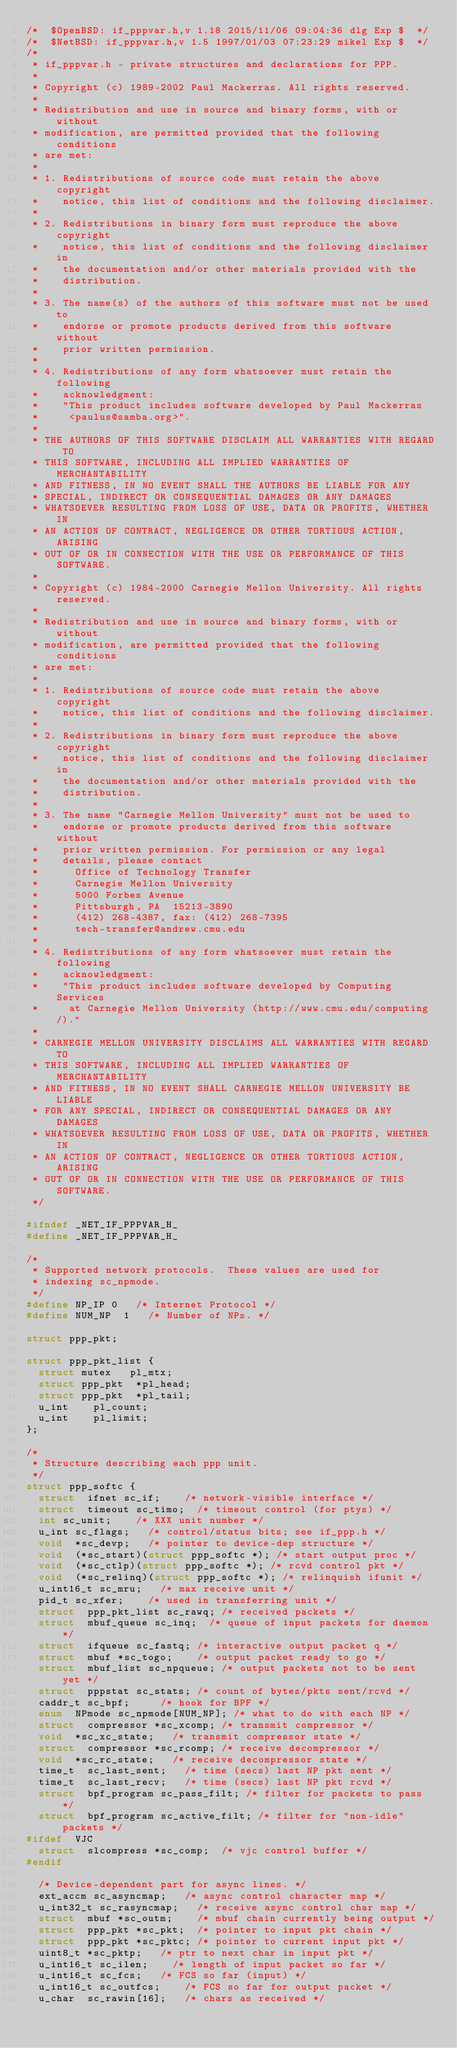Convert code to text. <code><loc_0><loc_0><loc_500><loc_500><_C_>/*	$OpenBSD: if_pppvar.h,v 1.18 2015/11/06 09:04:36 dlg Exp $	*/
/*	$NetBSD: if_pppvar.h,v 1.5 1997/01/03 07:23:29 mikel Exp $	*/
/*
 * if_pppvar.h - private structures and declarations for PPP.
 *
 * Copyright (c) 1989-2002 Paul Mackerras. All rights reserved.
 *
 * Redistribution and use in source and binary forms, with or without
 * modification, are permitted provided that the following conditions
 * are met:
 *
 * 1. Redistributions of source code must retain the above copyright
 *    notice, this list of conditions and the following disclaimer.
 *
 * 2. Redistributions in binary form must reproduce the above copyright
 *    notice, this list of conditions and the following disclaimer in
 *    the documentation and/or other materials provided with the
 *    distribution.
 *
 * 3. The name(s) of the authors of this software must not be used to
 *    endorse or promote products derived from this software without
 *    prior written permission.
 *
 * 4. Redistributions of any form whatsoever must retain the following
 *    acknowledgment:
 *    "This product includes software developed by Paul Mackerras
 *     <paulus@samba.org>".
 *
 * THE AUTHORS OF THIS SOFTWARE DISCLAIM ALL WARRANTIES WITH REGARD TO
 * THIS SOFTWARE, INCLUDING ALL IMPLIED WARRANTIES OF MERCHANTABILITY
 * AND FITNESS, IN NO EVENT SHALL THE AUTHORS BE LIABLE FOR ANY
 * SPECIAL, INDIRECT OR CONSEQUENTIAL DAMAGES OR ANY DAMAGES
 * WHATSOEVER RESULTING FROM LOSS OF USE, DATA OR PROFITS, WHETHER IN
 * AN ACTION OF CONTRACT, NEGLIGENCE OR OTHER TORTIOUS ACTION, ARISING
 * OUT OF OR IN CONNECTION WITH THE USE OR PERFORMANCE OF THIS SOFTWARE.
 *
 * Copyright (c) 1984-2000 Carnegie Mellon University. All rights reserved.
 *
 * Redistribution and use in source and binary forms, with or without
 * modification, are permitted provided that the following conditions
 * are met:
 *
 * 1. Redistributions of source code must retain the above copyright
 *    notice, this list of conditions and the following disclaimer.
 *
 * 2. Redistributions in binary form must reproduce the above copyright
 *    notice, this list of conditions and the following disclaimer in
 *    the documentation and/or other materials provided with the
 *    distribution.
 *
 * 3. The name "Carnegie Mellon University" must not be used to
 *    endorse or promote products derived from this software without
 *    prior written permission. For permission or any legal
 *    details, please contact
 *      Office of Technology Transfer
 *      Carnegie Mellon University
 *      5000 Forbes Avenue
 *      Pittsburgh, PA  15213-3890
 *      (412) 268-4387, fax: (412) 268-7395
 *      tech-transfer@andrew.cmu.edu
 *
 * 4. Redistributions of any form whatsoever must retain the following
 *    acknowledgment:
 *    "This product includes software developed by Computing Services
 *     at Carnegie Mellon University (http://www.cmu.edu/computing/)."
 *
 * CARNEGIE MELLON UNIVERSITY DISCLAIMS ALL WARRANTIES WITH REGARD TO
 * THIS SOFTWARE, INCLUDING ALL IMPLIED WARRANTIES OF MERCHANTABILITY
 * AND FITNESS, IN NO EVENT SHALL CARNEGIE MELLON UNIVERSITY BE LIABLE
 * FOR ANY SPECIAL, INDIRECT OR CONSEQUENTIAL DAMAGES OR ANY DAMAGES
 * WHATSOEVER RESULTING FROM LOSS OF USE, DATA OR PROFITS, WHETHER IN
 * AN ACTION OF CONTRACT, NEGLIGENCE OR OTHER TORTIOUS ACTION, ARISING
 * OUT OF OR IN CONNECTION WITH THE USE OR PERFORMANCE OF THIS SOFTWARE.
 */

#ifndef _NET_IF_PPPVAR_H_
#define _NET_IF_PPPVAR_H_

/*
 * Supported network protocols.  These values are used for
 * indexing sc_npmode.
 */
#define NP_IP	0		/* Internet Protocol */
#define NUM_NP	1		/* Number of NPs. */

struct ppp_pkt;

struct ppp_pkt_list {
	struct mutex	 pl_mtx;
	struct ppp_pkt	*pl_head;
	struct ppp_pkt	*pl_tail;
	u_int		 pl_count;
	u_int		 pl_limit;
};

/*
 * Structure describing each ppp unit.
 */
struct ppp_softc {
	struct	ifnet sc_if;		/* network-visible interface */
	struct	timeout sc_timo;	/* timeout control (for ptys) */
	int	sc_unit;		/* XXX unit number */
	u_int	sc_flags;		/* control/status bits; see if_ppp.h */
	void	*sc_devp;		/* pointer to device-dep structure */
	void	(*sc_start)(struct ppp_softc *); /* start output proc */
	void	(*sc_ctlp)(struct ppp_softc *); /* rcvd control pkt */
	void	(*sc_relinq)(struct ppp_softc *); /* relinquish ifunit */
	u_int16_t sc_mru;		/* max receive unit */
	pid_t	sc_xfer;		/* used in transferring unit */
	struct	ppp_pkt_list sc_rawq;	/* received packets */
	struct	mbuf_queue sc_inq;	/* queue of input packets for daemon */
	struct	ifqueue sc_fastq;	/* interactive output packet q */
	struct	mbuf *sc_togo;		/* output packet ready to go */
	struct	mbuf_list sc_npqueue;	/* output packets not to be sent yet */
	struct	pppstat sc_stats;	/* count of bytes/pkts sent/rcvd */
	caddr_t	sc_bpf;			/* hook for BPF */
	enum	NPmode sc_npmode[NUM_NP]; /* what to do with each NP */
	struct	compressor *sc_xcomp;	/* transmit compressor */
	void	*sc_xc_state;		/* transmit compressor state */
	struct	compressor *sc_rcomp;	/* receive decompressor */
	void	*sc_rc_state;		/* receive decompressor state */
	time_t	sc_last_sent;		/* time (secs) last NP pkt sent */
	time_t	sc_last_recv;		/* time (secs) last NP pkt rcvd */
	struct	bpf_program sc_pass_filt; /* filter for packets to pass */
	struct	bpf_program sc_active_filt; /* filter for "non-idle" packets */
#ifdef	VJC
	struct	slcompress *sc_comp; 	/* vjc control buffer */
#endif

	/* Device-dependent part for async lines. */
	ext_accm sc_asyncmap;		/* async control character map */
	u_int32_t sc_rasyncmap;		/* receive async control char map */
	struct	mbuf *sc_outm;		/* mbuf chain currently being output */
	struct	ppp_pkt *sc_pkt;	/* pointer to input pkt chain */
	struct	ppp_pkt *sc_pktc;	/* pointer to current input pkt */
	uint8_t	*sc_pktp;		/* ptr to next char in input pkt */
	u_int16_t sc_ilen;		/* length of input packet so far */
	u_int16_t sc_fcs;		/* FCS so far (input) */
	u_int16_t sc_outfcs;		/* FCS so far for output packet */
	u_char	sc_rawin[16];		/* chars as received */</code> 